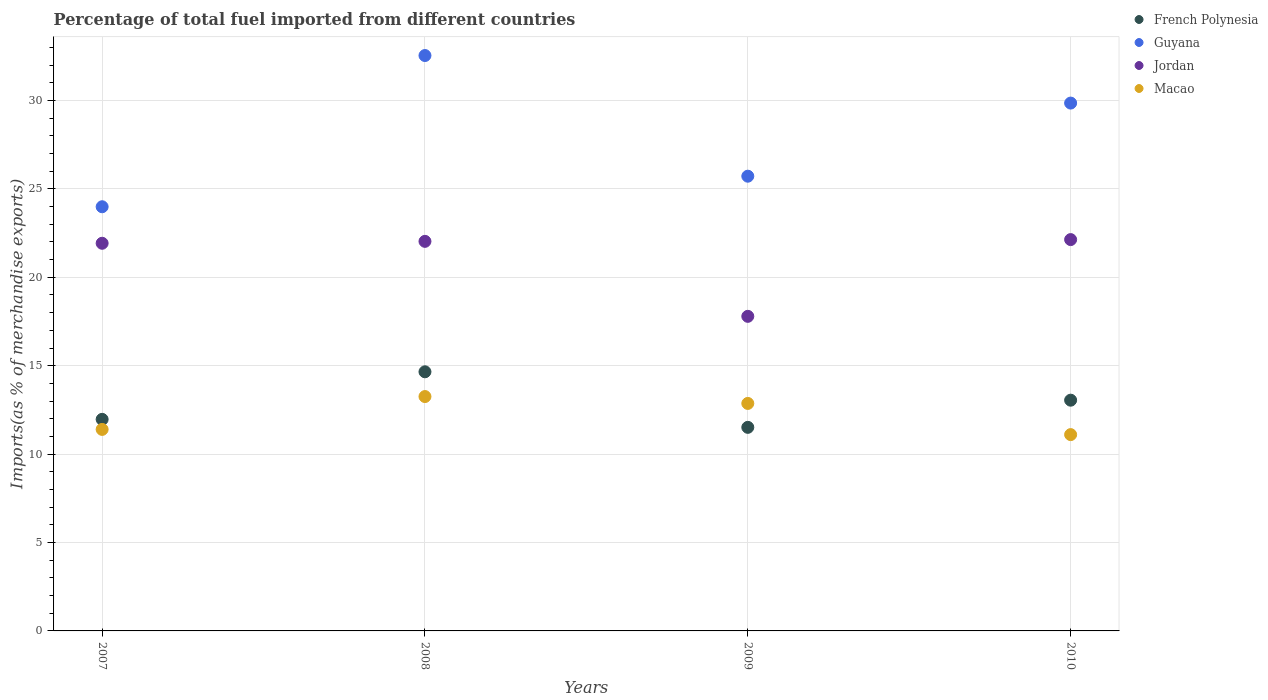How many different coloured dotlines are there?
Provide a short and direct response. 4. Is the number of dotlines equal to the number of legend labels?
Provide a succinct answer. Yes. What is the percentage of imports to different countries in Macao in 2008?
Your answer should be very brief. 13.26. Across all years, what is the maximum percentage of imports to different countries in French Polynesia?
Your answer should be very brief. 14.66. Across all years, what is the minimum percentage of imports to different countries in French Polynesia?
Ensure brevity in your answer.  11.51. In which year was the percentage of imports to different countries in French Polynesia maximum?
Provide a short and direct response. 2008. What is the total percentage of imports to different countries in Guyana in the graph?
Your answer should be compact. 112.11. What is the difference between the percentage of imports to different countries in Guyana in 2008 and that in 2009?
Give a very brief answer. 6.82. What is the difference between the percentage of imports to different countries in Macao in 2008 and the percentage of imports to different countries in Jordan in 2007?
Offer a terse response. -8.67. What is the average percentage of imports to different countries in French Polynesia per year?
Your answer should be compact. 12.8. In the year 2008, what is the difference between the percentage of imports to different countries in French Polynesia and percentage of imports to different countries in Guyana?
Make the answer very short. -17.89. In how many years, is the percentage of imports to different countries in Guyana greater than 7 %?
Make the answer very short. 4. What is the ratio of the percentage of imports to different countries in Jordan in 2008 to that in 2009?
Offer a terse response. 1.24. Is the percentage of imports to different countries in Guyana in 2007 less than that in 2009?
Ensure brevity in your answer.  Yes. What is the difference between the highest and the second highest percentage of imports to different countries in Guyana?
Your response must be concise. 2.69. What is the difference between the highest and the lowest percentage of imports to different countries in Guyana?
Provide a succinct answer. 8.55. Is it the case that in every year, the sum of the percentage of imports to different countries in Jordan and percentage of imports to different countries in Macao  is greater than the sum of percentage of imports to different countries in Guyana and percentage of imports to different countries in French Polynesia?
Ensure brevity in your answer.  No. Is it the case that in every year, the sum of the percentage of imports to different countries in Guyana and percentage of imports to different countries in French Polynesia  is greater than the percentage of imports to different countries in Macao?
Provide a succinct answer. Yes. Does the percentage of imports to different countries in Macao monotonically increase over the years?
Make the answer very short. No. Is the percentage of imports to different countries in Jordan strictly greater than the percentage of imports to different countries in Guyana over the years?
Provide a succinct answer. No. Is the percentage of imports to different countries in Macao strictly less than the percentage of imports to different countries in Jordan over the years?
Provide a short and direct response. Yes. How many dotlines are there?
Your answer should be very brief. 4. Are the values on the major ticks of Y-axis written in scientific E-notation?
Offer a very short reply. No. Does the graph contain any zero values?
Ensure brevity in your answer.  No. How many legend labels are there?
Provide a succinct answer. 4. What is the title of the graph?
Offer a very short reply. Percentage of total fuel imported from different countries. Does "Kiribati" appear as one of the legend labels in the graph?
Keep it short and to the point. No. What is the label or title of the X-axis?
Offer a terse response. Years. What is the label or title of the Y-axis?
Your answer should be very brief. Imports(as % of merchandise exports). What is the Imports(as % of merchandise exports) in French Polynesia in 2007?
Your answer should be compact. 11.97. What is the Imports(as % of merchandise exports) in Guyana in 2007?
Provide a short and direct response. 23.99. What is the Imports(as % of merchandise exports) of Jordan in 2007?
Your answer should be very brief. 21.93. What is the Imports(as % of merchandise exports) in Macao in 2007?
Provide a succinct answer. 11.4. What is the Imports(as % of merchandise exports) in French Polynesia in 2008?
Make the answer very short. 14.66. What is the Imports(as % of merchandise exports) in Guyana in 2008?
Provide a short and direct response. 32.54. What is the Imports(as % of merchandise exports) of Jordan in 2008?
Offer a very short reply. 22.03. What is the Imports(as % of merchandise exports) of Macao in 2008?
Give a very brief answer. 13.26. What is the Imports(as % of merchandise exports) in French Polynesia in 2009?
Make the answer very short. 11.51. What is the Imports(as % of merchandise exports) in Guyana in 2009?
Your response must be concise. 25.72. What is the Imports(as % of merchandise exports) of Jordan in 2009?
Your answer should be compact. 17.79. What is the Imports(as % of merchandise exports) of Macao in 2009?
Provide a short and direct response. 12.87. What is the Imports(as % of merchandise exports) of French Polynesia in 2010?
Provide a short and direct response. 13.05. What is the Imports(as % of merchandise exports) in Guyana in 2010?
Provide a succinct answer. 29.85. What is the Imports(as % of merchandise exports) of Jordan in 2010?
Offer a very short reply. 22.13. What is the Imports(as % of merchandise exports) of Macao in 2010?
Keep it short and to the point. 11.1. Across all years, what is the maximum Imports(as % of merchandise exports) in French Polynesia?
Offer a terse response. 14.66. Across all years, what is the maximum Imports(as % of merchandise exports) of Guyana?
Provide a succinct answer. 32.54. Across all years, what is the maximum Imports(as % of merchandise exports) in Jordan?
Make the answer very short. 22.13. Across all years, what is the maximum Imports(as % of merchandise exports) in Macao?
Make the answer very short. 13.26. Across all years, what is the minimum Imports(as % of merchandise exports) in French Polynesia?
Your response must be concise. 11.51. Across all years, what is the minimum Imports(as % of merchandise exports) in Guyana?
Offer a terse response. 23.99. Across all years, what is the minimum Imports(as % of merchandise exports) of Jordan?
Make the answer very short. 17.79. Across all years, what is the minimum Imports(as % of merchandise exports) in Macao?
Ensure brevity in your answer.  11.1. What is the total Imports(as % of merchandise exports) in French Polynesia in the graph?
Your response must be concise. 51.19. What is the total Imports(as % of merchandise exports) of Guyana in the graph?
Give a very brief answer. 112.11. What is the total Imports(as % of merchandise exports) in Jordan in the graph?
Provide a short and direct response. 83.88. What is the total Imports(as % of merchandise exports) in Macao in the graph?
Offer a terse response. 48.62. What is the difference between the Imports(as % of merchandise exports) in French Polynesia in 2007 and that in 2008?
Keep it short and to the point. -2.69. What is the difference between the Imports(as % of merchandise exports) in Guyana in 2007 and that in 2008?
Ensure brevity in your answer.  -8.55. What is the difference between the Imports(as % of merchandise exports) in Jordan in 2007 and that in 2008?
Provide a succinct answer. -0.11. What is the difference between the Imports(as % of merchandise exports) of Macao in 2007 and that in 2008?
Give a very brief answer. -1.86. What is the difference between the Imports(as % of merchandise exports) of French Polynesia in 2007 and that in 2009?
Give a very brief answer. 0.45. What is the difference between the Imports(as % of merchandise exports) in Guyana in 2007 and that in 2009?
Ensure brevity in your answer.  -1.73. What is the difference between the Imports(as % of merchandise exports) in Jordan in 2007 and that in 2009?
Your response must be concise. 4.13. What is the difference between the Imports(as % of merchandise exports) of Macao in 2007 and that in 2009?
Your response must be concise. -1.47. What is the difference between the Imports(as % of merchandise exports) of French Polynesia in 2007 and that in 2010?
Provide a short and direct response. -1.08. What is the difference between the Imports(as % of merchandise exports) in Guyana in 2007 and that in 2010?
Give a very brief answer. -5.86. What is the difference between the Imports(as % of merchandise exports) of Jordan in 2007 and that in 2010?
Provide a succinct answer. -0.21. What is the difference between the Imports(as % of merchandise exports) of Macao in 2007 and that in 2010?
Offer a terse response. 0.29. What is the difference between the Imports(as % of merchandise exports) of French Polynesia in 2008 and that in 2009?
Offer a terse response. 3.14. What is the difference between the Imports(as % of merchandise exports) in Guyana in 2008 and that in 2009?
Your response must be concise. 6.82. What is the difference between the Imports(as % of merchandise exports) in Jordan in 2008 and that in 2009?
Provide a short and direct response. 4.24. What is the difference between the Imports(as % of merchandise exports) in Macao in 2008 and that in 2009?
Ensure brevity in your answer.  0.39. What is the difference between the Imports(as % of merchandise exports) of French Polynesia in 2008 and that in 2010?
Keep it short and to the point. 1.61. What is the difference between the Imports(as % of merchandise exports) in Guyana in 2008 and that in 2010?
Ensure brevity in your answer.  2.69. What is the difference between the Imports(as % of merchandise exports) of Jordan in 2008 and that in 2010?
Provide a short and direct response. -0.1. What is the difference between the Imports(as % of merchandise exports) in Macao in 2008 and that in 2010?
Make the answer very short. 2.15. What is the difference between the Imports(as % of merchandise exports) in French Polynesia in 2009 and that in 2010?
Offer a terse response. -1.54. What is the difference between the Imports(as % of merchandise exports) in Guyana in 2009 and that in 2010?
Offer a very short reply. -4.14. What is the difference between the Imports(as % of merchandise exports) of Jordan in 2009 and that in 2010?
Your answer should be very brief. -4.34. What is the difference between the Imports(as % of merchandise exports) of Macao in 2009 and that in 2010?
Offer a very short reply. 1.76. What is the difference between the Imports(as % of merchandise exports) in French Polynesia in 2007 and the Imports(as % of merchandise exports) in Guyana in 2008?
Make the answer very short. -20.58. What is the difference between the Imports(as % of merchandise exports) in French Polynesia in 2007 and the Imports(as % of merchandise exports) in Jordan in 2008?
Offer a very short reply. -10.07. What is the difference between the Imports(as % of merchandise exports) in French Polynesia in 2007 and the Imports(as % of merchandise exports) in Macao in 2008?
Your answer should be compact. -1.29. What is the difference between the Imports(as % of merchandise exports) in Guyana in 2007 and the Imports(as % of merchandise exports) in Jordan in 2008?
Ensure brevity in your answer.  1.96. What is the difference between the Imports(as % of merchandise exports) in Guyana in 2007 and the Imports(as % of merchandise exports) in Macao in 2008?
Your answer should be compact. 10.73. What is the difference between the Imports(as % of merchandise exports) in Jordan in 2007 and the Imports(as % of merchandise exports) in Macao in 2008?
Provide a succinct answer. 8.67. What is the difference between the Imports(as % of merchandise exports) in French Polynesia in 2007 and the Imports(as % of merchandise exports) in Guyana in 2009?
Keep it short and to the point. -13.75. What is the difference between the Imports(as % of merchandise exports) of French Polynesia in 2007 and the Imports(as % of merchandise exports) of Jordan in 2009?
Provide a short and direct response. -5.83. What is the difference between the Imports(as % of merchandise exports) in French Polynesia in 2007 and the Imports(as % of merchandise exports) in Macao in 2009?
Ensure brevity in your answer.  -0.9. What is the difference between the Imports(as % of merchandise exports) of Guyana in 2007 and the Imports(as % of merchandise exports) of Jordan in 2009?
Offer a very short reply. 6.2. What is the difference between the Imports(as % of merchandise exports) in Guyana in 2007 and the Imports(as % of merchandise exports) in Macao in 2009?
Keep it short and to the point. 11.12. What is the difference between the Imports(as % of merchandise exports) of Jordan in 2007 and the Imports(as % of merchandise exports) of Macao in 2009?
Offer a terse response. 9.06. What is the difference between the Imports(as % of merchandise exports) of French Polynesia in 2007 and the Imports(as % of merchandise exports) of Guyana in 2010?
Your answer should be compact. -17.89. What is the difference between the Imports(as % of merchandise exports) of French Polynesia in 2007 and the Imports(as % of merchandise exports) of Jordan in 2010?
Give a very brief answer. -10.17. What is the difference between the Imports(as % of merchandise exports) in French Polynesia in 2007 and the Imports(as % of merchandise exports) in Macao in 2010?
Offer a terse response. 0.86. What is the difference between the Imports(as % of merchandise exports) in Guyana in 2007 and the Imports(as % of merchandise exports) in Jordan in 2010?
Offer a terse response. 1.86. What is the difference between the Imports(as % of merchandise exports) in Guyana in 2007 and the Imports(as % of merchandise exports) in Macao in 2010?
Offer a very short reply. 12.89. What is the difference between the Imports(as % of merchandise exports) of Jordan in 2007 and the Imports(as % of merchandise exports) of Macao in 2010?
Provide a short and direct response. 10.82. What is the difference between the Imports(as % of merchandise exports) of French Polynesia in 2008 and the Imports(as % of merchandise exports) of Guyana in 2009?
Your answer should be very brief. -11.06. What is the difference between the Imports(as % of merchandise exports) of French Polynesia in 2008 and the Imports(as % of merchandise exports) of Jordan in 2009?
Offer a terse response. -3.14. What is the difference between the Imports(as % of merchandise exports) of French Polynesia in 2008 and the Imports(as % of merchandise exports) of Macao in 2009?
Offer a terse response. 1.79. What is the difference between the Imports(as % of merchandise exports) of Guyana in 2008 and the Imports(as % of merchandise exports) of Jordan in 2009?
Ensure brevity in your answer.  14.75. What is the difference between the Imports(as % of merchandise exports) in Guyana in 2008 and the Imports(as % of merchandise exports) in Macao in 2009?
Ensure brevity in your answer.  19.68. What is the difference between the Imports(as % of merchandise exports) in Jordan in 2008 and the Imports(as % of merchandise exports) in Macao in 2009?
Give a very brief answer. 9.17. What is the difference between the Imports(as % of merchandise exports) in French Polynesia in 2008 and the Imports(as % of merchandise exports) in Guyana in 2010?
Your response must be concise. -15.2. What is the difference between the Imports(as % of merchandise exports) of French Polynesia in 2008 and the Imports(as % of merchandise exports) of Jordan in 2010?
Offer a terse response. -7.48. What is the difference between the Imports(as % of merchandise exports) in French Polynesia in 2008 and the Imports(as % of merchandise exports) in Macao in 2010?
Make the answer very short. 3.55. What is the difference between the Imports(as % of merchandise exports) in Guyana in 2008 and the Imports(as % of merchandise exports) in Jordan in 2010?
Make the answer very short. 10.41. What is the difference between the Imports(as % of merchandise exports) in Guyana in 2008 and the Imports(as % of merchandise exports) in Macao in 2010?
Your answer should be compact. 21.44. What is the difference between the Imports(as % of merchandise exports) of Jordan in 2008 and the Imports(as % of merchandise exports) of Macao in 2010?
Your response must be concise. 10.93. What is the difference between the Imports(as % of merchandise exports) in French Polynesia in 2009 and the Imports(as % of merchandise exports) in Guyana in 2010?
Keep it short and to the point. -18.34. What is the difference between the Imports(as % of merchandise exports) in French Polynesia in 2009 and the Imports(as % of merchandise exports) in Jordan in 2010?
Offer a very short reply. -10.62. What is the difference between the Imports(as % of merchandise exports) in French Polynesia in 2009 and the Imports(as % of merchandise exports) in Macao in 2010?
Make the answer very short. 0.41. What is the difference between the Imports(as % of merchandise exports) of Guyana in 2009 and the Imports(as % of merchandise exports) of Jordan in 2010?
Keep it short and to the point. 3.59. What is the difference between the Imports(as % of merchandise exports) in Guyana in 2009 and the Imports(as % of merchandise exports) in Macao in 2010?
Provide a short and direct response. 14.62. What is the difference between the Imports(as % of merchandise exports) of Jordan in 2009 and the Imports(as % of merchandise exports) of Macao in 2010?
Offer a very short reply. 6.69. What is the average Imports(as % of merchandise exports) in French Polynesia per year?
Your answer should be very brief. 12.8. What is the average Imports(as % of merchandise exports) of Guyana per year?
Provide a succinct answer. 28.03. What is the average Imports(as % of merchandise exports) of Jordan per year?
Your answer should be compact. 20.97. What is the average Imports(as % of merchandise exports) of Macao per year?
Offer a very short reply. 12.16. In the year 2007, what is the difference between the Imports(as % of merchandise exports) of French Polynesia and Imports(as % of merchandise exports) of Guyana?
Ensure brevity in your answer.  -12.02. In the year 2007, what is the difference between the Imports(as % of merchandise exports) in French Polynesia and Imports(as % of merchandise exports) in Jordan?
Make the answer very short. -9.96. In the year 2007, what is the difference between the Imports(as % of merchandise exports) in French Polynesia and Imports(as % of merchandise exports) in Macao?
Provide a succinct answer. 0.57. In the year 2007, what is the difference between the Imports(as % of merchandise exports) in Guyana and Imports(as % of merchandise exports) in Jordan?
Your answer should be very brief. 2.07. In the year 2007, what is the difference between the Imports(as % of merchandise exports) in Guyana and Imports(as % of merchandise exports) in Macao?
Your response must be concise. 12.59. In the year 2007, what is the difference between the Imports(as % of merchandise exports) in Jordan and Imports(as % of merchandise exports) in Macao?
Offer a very short reply. 10.53. In the year 2008, what is the difference between the Imports(as % of merchandise exports) of French Polynesia and Imports(as % of merchandise exports) of Guyana?
Offer a very short reply. -17.89. In the year 2008, what is the difference between the Imports(as % of merchandise exports) in French Polynesia and Imports(as % of merchandise exports) in Jordan?
Make the answer very short. -7.38. In the year 2008, what is the difference between the Imports(as % of merchandise exports) of French Polynesia and Imports(as % of merchandise exports) of Macao?
Provide a succinct answer. 1.4. In the year 2008, what is the difference between the Imports(as % of merchandise exports) of Guyana and Imports(as % of merchandise exports) of Jordan?
Provide a succinct answer. 10.51. In the year 2008, what is the difference between the Imports(as % of merchandise exports) of Guyana and Imports(as % of merchandise exports) of Macao?
Offer a very short reply. 19.29. In the year 2008, what is the difference between the Imports(as % of merchandise exports) in Jordan and Imports(as % of merchandise exports) in Macao?
Your response must be concise. 8.78. In the year 2009, what is the difference between the Imports(as % of merchandise exports) of French Polynesia and Imports(as % of merchandise exports) of Guyana?
Your answer should be very brief. -14.21. In the year 2009, what is the difference between the Imports(as % of merchandise exports) in French Polynesia and Imports(as % of merchandise exports) in Jordan?
Provide a succinct answer. -6.28. In the year 2009, what is the difference between the Imports(as % of merchandise exports) in French Polynesia and Imports(as % of merchandise exports) in Macao?
Your response must be concise. -1.35. In the year 2009, what is the difference between the Imports(as % of merchandise exports) of Guyana and Imports(as % of merchandise exports) of Jordan?
Offer a very short reply. 7.93. In the year 2009, what is the difference between the Imports(as % of merchandise exports) in Guyana and Imports(as % of merchandise exports) in Macao?
Keep it short and to the point. 12.85. In the year 2009, what is the difference between the Imports(as % of merchandise exports) of Jordan and Imports(as % of merchandise exports) of Macao?
Keep it short and to the point. 4.93. In the year 2010, what is the difference between the Imports(as % of merchandise exports) in French Polynesia and Imports(as % of merchandise exports) in Guyana?
Offer a terse response. -16.8. In the year 2010, what is the difference between the Imports(as % of merchandise exports) in French Polynesia and Imports(as % of merchandise exports) in Jordan?
Your answer should be very brief. -9.08. In the year 2010, what is the difference between the Imports(as % of merchandise exports) of French Polynesia and Imports(as % of merchandise exports) of Macao?
Provide a short and direct response. 1.95. In the year 2010, what is the difference between the Imports(as % of merchandise exports) of Guyana and Imports(as % of merchandise exports) of Jordan?
Your answer should be compact. 7.72. In the year 2010, what is the difference between the Imports(as % of merchandise exports) in Guyana and Imports(as % of merchandise exports) in Macao?
Your answer should be very brief. 18.75. In the year 2010, what is the difference between the Imports(as % of merchandise exports) in Jordan and Imports(as % of merchandise exports) in Macao?
Your answer should be very brief. 11.03. What is the ratio of the Imports(as % of merchandise exports) of French Polynesia in 2007 to that in 2008?
Offer a terse response. 0.82. What is the ratio of the Imports(as % of merchandise exports) of Guyana in 2007 to that in 2008?
Provide a short and direct response. 0.74. What is the ratio of the Imports(as % of merchandise exports) of Jordan in 2007 to that in 2008?
Provide a succinct answer. 1. What is the ratio of the Imports(as % of merchandise exports) of Macao in 2007 to that in 2008?
Ensure brevity in your answer.  0.86. What is the ratio of the Imports(as % of merchandise exports) in French Polynesia in 2007 to that in 2009?
Ensure brevity in your answer.  1.04. What is the ratio of the Imports(as % of merchandise exports) of Guyana in 2007 to that in 2009?
Provide a succinct answer. 0.93. What is the ratio of the Imports(as % of merchandise exports) in Jordan in 2007 to that in 2009?
Keep it short and to the point. 1.23. What is the ratio of the Imports(as % of merchandise exports) in Macao in 2007 to that in 2009?
Keep it short and to the point. 0.89. What is the ratio of the Imports(as % of merchandise exports) of French Polynesia in 2007 to that in 2010?
Keep it short and to the point. 0.92. What is the ratio of the Imports(as % of merchandise exports) in Guyana in 2007 to that in 2010?
Give a very brief answer. 0.8. What is the ratio of the Imports(as % of merchandise exports) of Jordan in 2007 to that in 2010?
Provide a succinct answer. 0.99. What is the ratio of the Imports(as % of merchandise exports) of Macao in 2007 to that in 2010?
Provide a short and direct response. 1.03. What is the ratio of the Imports(as % of merchandise exports) of French Polynesia in 2008 to that in 2009?
Give a very brief answer. 1.27. What is the ratio of the Imports(as % of merchandise exports) of Guyana in 2008 to that in 2009?
Ensure brevity in your answer.  1.27. What is the ratio of the Imports(as % of merchandise exports) in Jordan in 2008 to that in 2009?
Your answer should be very brief. 1.24. What is the ratio of the Imports(as % of merchandise exports) in Macao in 2008 to that in 2009?
Offer a very short reply. 1.03. What is the ratio of the Imports(as % of merchandise exports) of French Polynesia in 2008 to that in 2010?
Offer a very short reply. 1.12. What is the ratio of the Imports(as % of merchandise exports) of Guyana in 2008 to that in 2010?
Keep it short and to the point. 1.09. What is the ratio of the Imports(as % of merchandise exports) in Jordan in 2008 to that in 2010?
Ensure brevity in your answer.  1. What is the ratio of the Imports(as % of merchandise exports) of Macao in 2008 to that in 2010?
Provide a succinct answer. 1.19. What is the ratio of the Imports(as % of merchandise exports) in French Polynesia in 2009 to that in 2010?
Offer a terse response. 0.88. What is the ratio of the Imports(as % of merchandise exports) in Guyana in 2009 to that in 2010?
Give a very brief answer. 0.86. What is the ratio of the Imports(as % of merchandise exports) of Jordan in 2009 to that in 2010?
Keep it short and to the point. 0.8. What is the ratio of the Imports(as % of merchandise exports) of Macao in 2009 to that in 2010?
Give a very brief answer. 1.16. What is the difference between the highest and the second highest Imports(as % of merchandise exports) in French Polynesia?
Provide a short and direct response. 1.61. What is the difference between the highest and the second highest Imports(as % of merchandise exports) in Guyana?
Keep it short and to the point. 2.69. What is the difference between the highest and the second highest Imports(as % of merchandise exports) of Jordan?
Your response must be concise. 0.1. What is the difference between the highest and the second highest Imports(as % of merchandise exports) of Macao?
Your answer should be very brief. 0.39. What is the difference between the highest and the lowest Imports(as % of merchandise exports) of French Polynesia?
Offer a very short reply. 3.14. What is the difference between the highest and the lowest Imports(as % of merchandise exports) of Guyana?
Offer a terse response. 8.55. What is the difference between the highest and the lowest Imports(as % of merchandise exports) in Jordan?
Your response must be concise. 4.34. What is the difference between the highest and the lowest Imports(as % of merchandise exports) in Macao?
Offer a terse response. 2.15. 